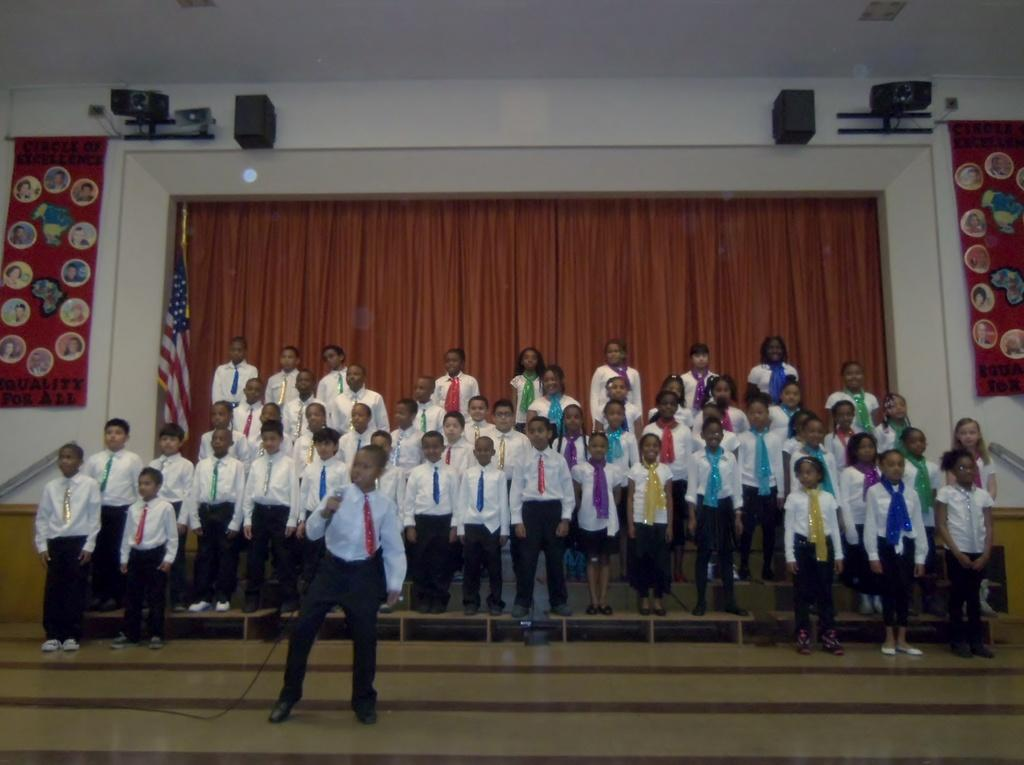What is the boy in the image holding? The boy is holding a microphone in the image. Can you describe the group of people in the image? There is a group of people standing in the image. What type of fabric is present in the image? There are curtains in the image. What symbol can be seen in the image? There is a flag in the image. What is attached to the wall in the image? There are banners on the wall in the image. What device is used for amplifying sound in the image? There are speakers in the image. How many snails are crawling on the boy's head in the image? There are no snails present in the image. 